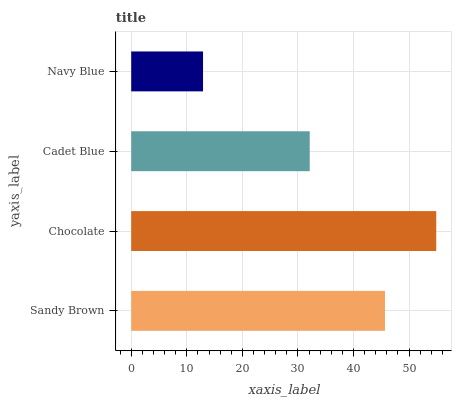Is Navy Blue the minimum?
Answer yes or no. Yes. Is Chocolate the maximum?
Answer yes or no. Yes. Is Cadet Blue the minimum?
Answer yes or no. No. Is Cadet Blue the maximum?
Answer yes or no. No. Is Chocolate greater than Cadet Blue?
Answer yes or no. Yes. Is Cadet Blue less than Chocolate?
Answer yes or no. Yes. Is Cadet Blue greater than Chocolate?
Answer yes or no. No. Is Chocolate less than Cadet Blue?
Answer yes or no. No. Is Sandy Brown the high median?
Answer yes or no. Yes. Is Cadet Blue the low median?
Answer yes or no. Yes. Is Navy Blue the high median?
Answer yes or no. No. Is Chocolate the low median?
Answer yes or no. No. 